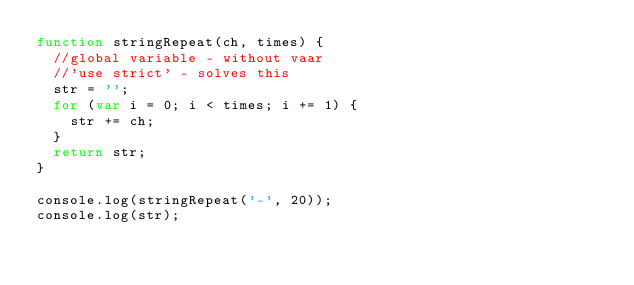<code> <loc_0><loc_0><loc_500><loc_500><_JavaScript_>function stringRepeat(ch, times) {
	//global variable - without vaar
	//'use strict' - solves this
	str = '';
	for (var i = 0; i < times; i += 1) {
		str += ch;
	}
	return str;
}

console.log(stringRepeat('-', 20));
console.log(str);</code> 